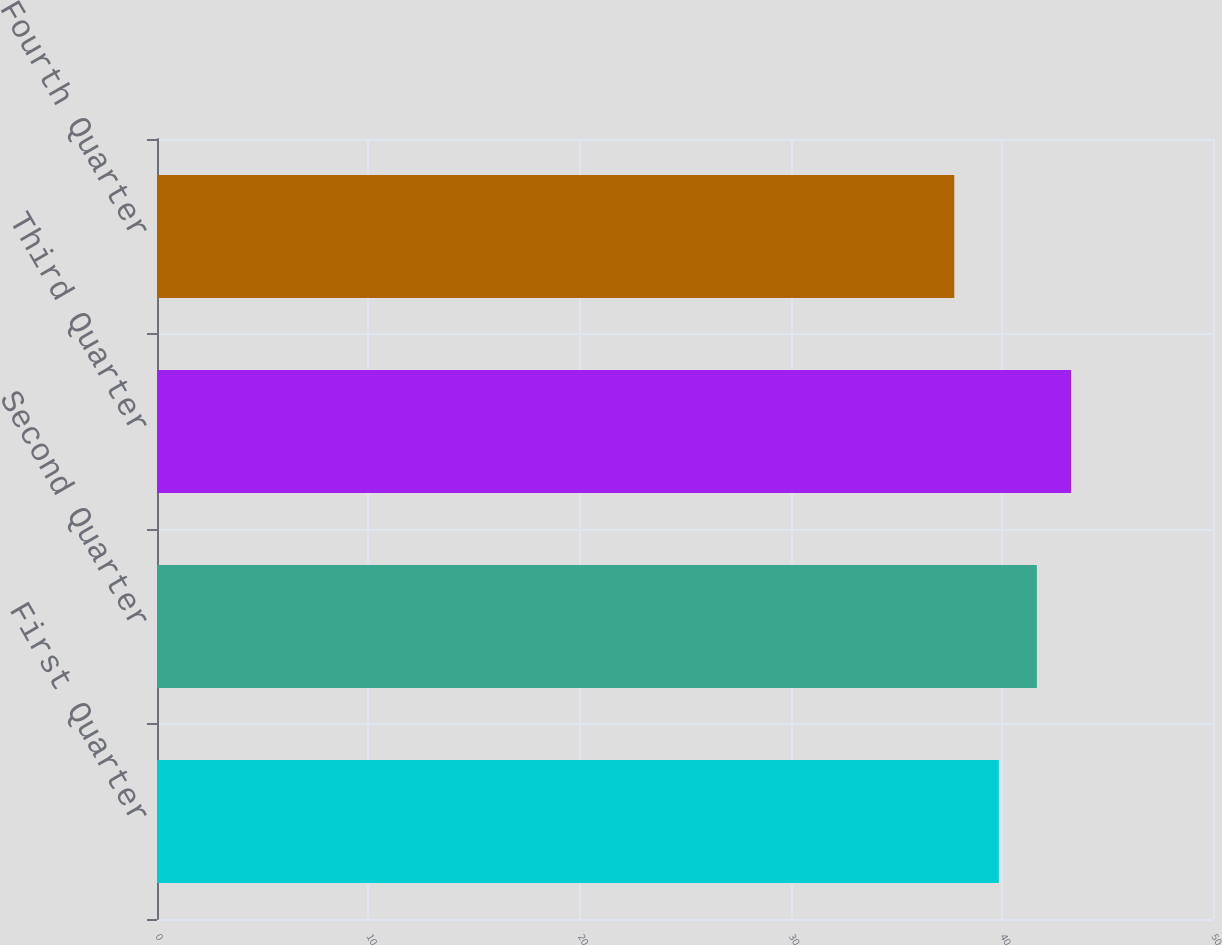<chart> <loc_0><loc_0><loc_500><loc_500><bar_chart><fcel>First Quarter<fcel>Second Quarter<fcel>Third Quarter<fcel>Fourth Quarter<nl><fcel>39.86<fcel>41.66<fcel>43.28<fcel>37.75<nl></chart> 